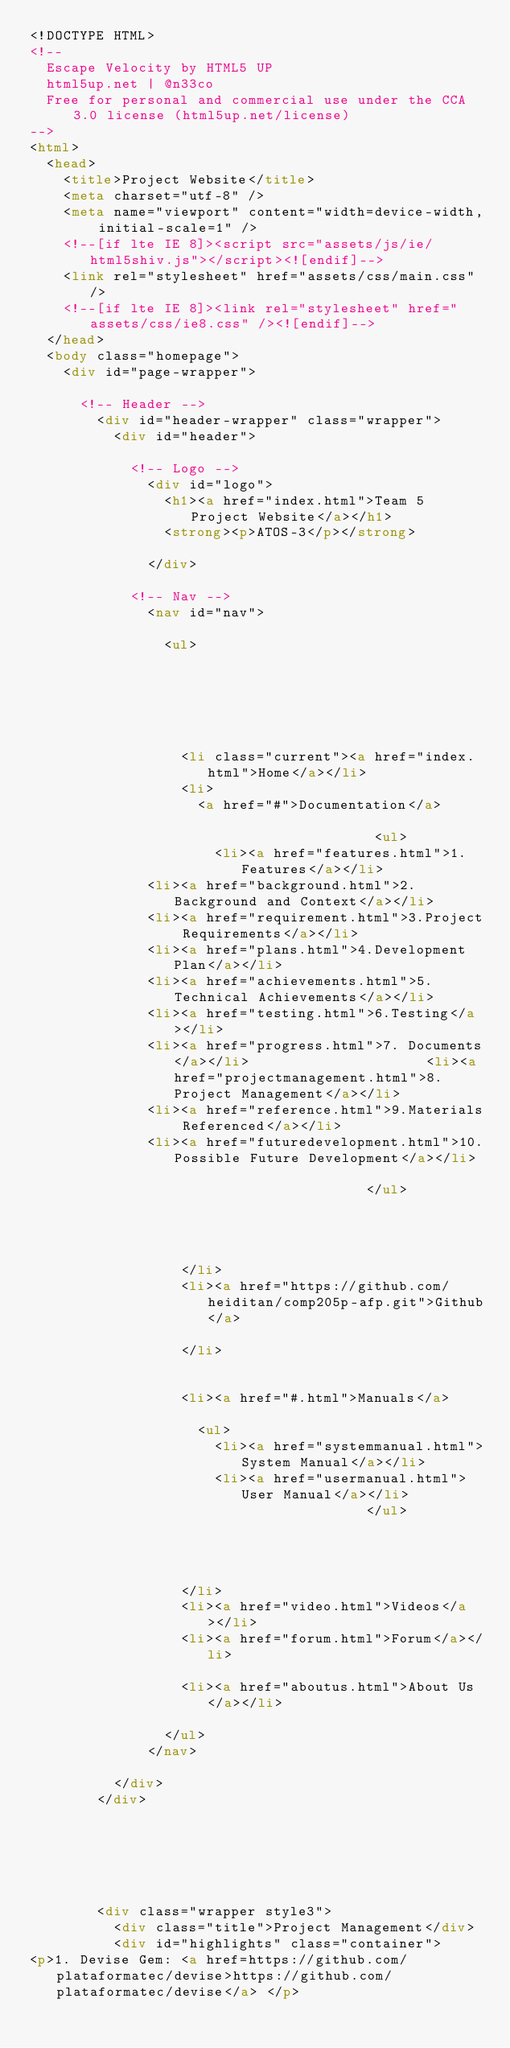Convert code to text. <code><loc_0><loc_0><loc_500><loc_500><_HTML_><!DOCTYPE HTML>
<!--
	Escape Velocity by HTML5 UP
	html5up.net | @n33co
	Free for personal and commercial use under the CCA 3.0 license (html5up.net/license)
-->
<html>
	<head>
		<title>Project Website</title>
		<meta charset="utf-8" />
		<meta name="viewport" content="width=device-width, initial-scale=1" />
		<!--[if lte IE 8]><script src="assets/js/ie/html5shiv.js"></script><![endif]-->
		<link rel="stylesheet" href="assets/css/main.css" />
		<!--[if lte IE 8]><link rel="stylesheet" href="assets/css/ie8.css" /><![endif]-->
	</head>
	<body class="homepage">
		<div id="page-wrapper">

			<!-- Header -->
				<div id="header-wrapper" class="wrapper">
					<div id="header">

						<!-- Logo -->
							<div id="logo">
								<h1><a href="index.html">Team 5 Project Website</a></h1>
								<strong><p>ATOS-3</p></strong>
								
							</div>

						<!-- Nav -->
							<nav id="nav">

								<ul>
									
                                    
									
                                    
									
							
									<li class="current"><a href="index.html">Home</a></li>
									<li>
										<a href="#">Documentation</a>

                                         <ul>
											<li><a href="features.html">1.Features</a></li>
							<li><a href="background.html">2.Background and Context</a></li>
							<li><a href="requirement.html">3.Project Requirements</a></li>
							<li><a href="plans.html">4.Development Plan</a></li>
							<li><a href="achievements.html">5.Technical Achievements</a></li>
							<li><a href="testing.html">6.Testing</a></li>
							<li><a href="progress.html">7. Documents</a></li>											<li><a href="projectmanagement.html">8.Project Management</a></li>
							<li><a href="reference.html">9.Materials Referenced</a></li>
							<li><a href="futuredevelopment.html">10.Possible Future Development</a></li>
											
                                        </ul>

										
										
											
									</li>
									<li><a href="https://github.com/heiditan/comp205p-afp.git">Github</a>
									
									</li>
									
									
									<li><a href="#.html">Manuals</a>

										<ul>
											<li><a href="systemmanual.html">System Manual</a></li>
											<li><a href="usermanual.html">User Manual</a></li>
                                        </ul>

     


									</li>
									<li><a href="video.html">Videos</a></li>
									<li><a href="forum.html">Forum</a></li>
								
									<li><a href="aboutus.html">About Us</a></li>
									
								</ul>
							</nav>

					</div>
				</div>






				<div class="wrapper style3">
					<div class="title">Project Management</div>
					<div id="highlights" class="container">
<p>1.	Devise Gem: <a href=https://github.com/plataformatec/devise>https://github.com/plataformatec/devise</a> </p></code> 